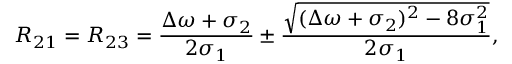Convert formula to latex. <formula><loc_0><loc_0><loc_500><loc_500>R _ { 2 1 } = R _ { 2 3 } = \frac { \Delta \omega + \sigma _ { 2 } } { 2 \sigma _ { 1 } } \pm \frac { \sqrt { ( \Delta \omega + \sigma _ { 2 } ) ^ { 2 } - 8 \sigma _ { 1 } ^ { 2 } } } { 2 \sigma _ { 1 } } ,</formula> 